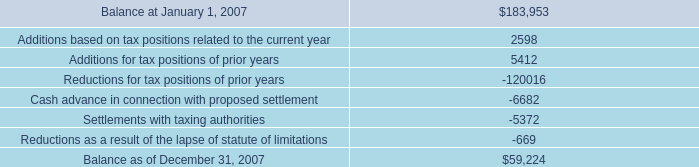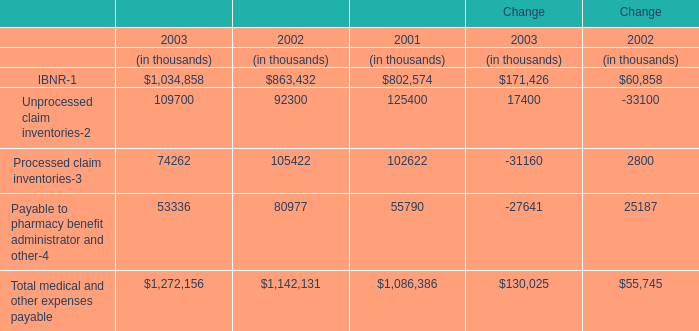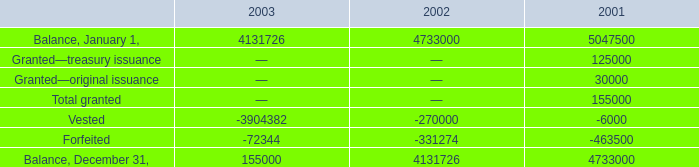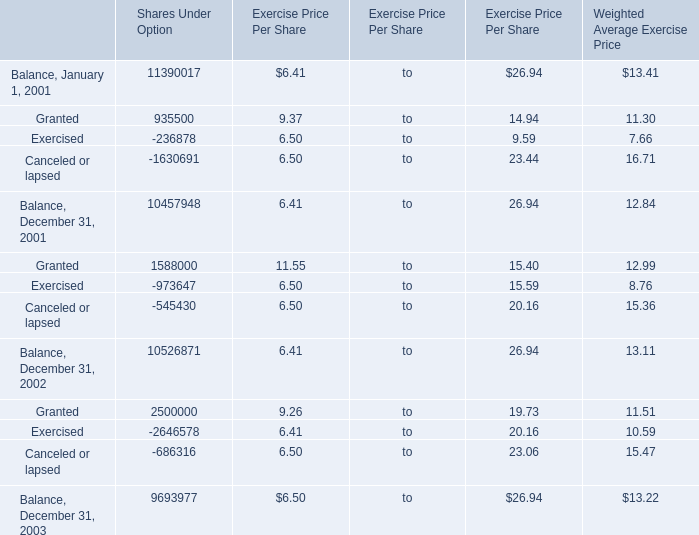What is the sum of Settlements with taxing authorities, and Balance, December 31, of 2003 ? 
Computations: (5372.0 + 155000.0)
Answer: 160372.0. 